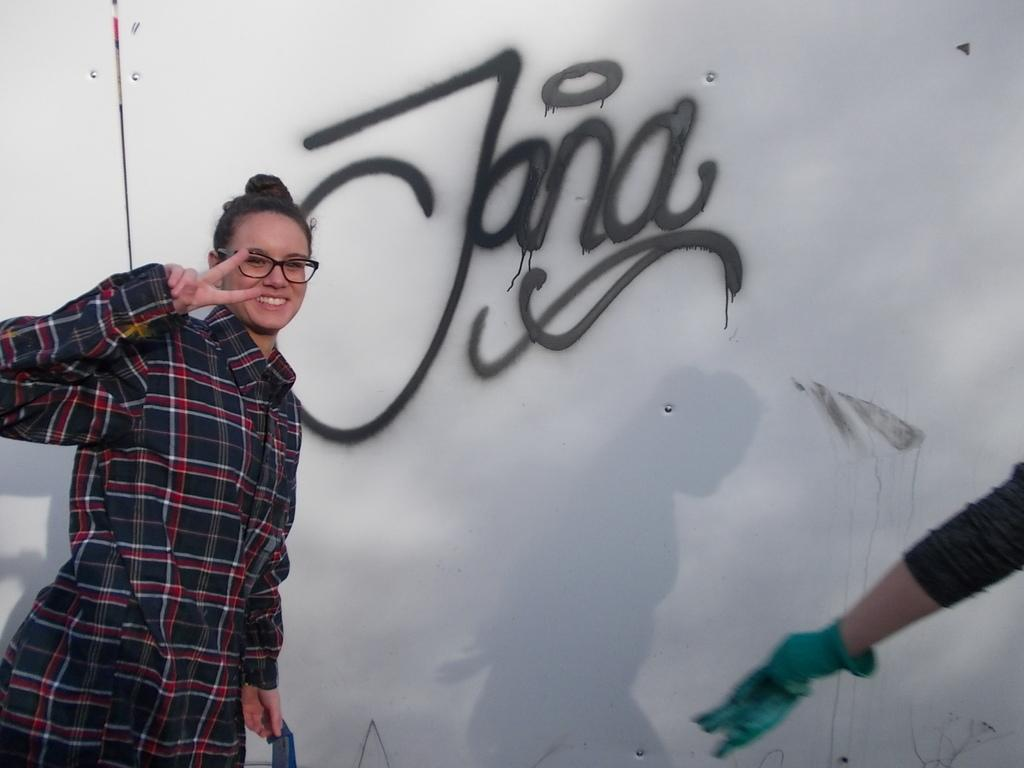Who is present in the image? There is a woman in the image. What can be seen in the background of the image? There is a painted wall visible in the background of the image. How many spiders are crawling on the woman in the image? There are no spiders visible in the image; it only features a woman and a painted wall in the background. What act is the woman performing in the image? The image does not depict the woman performing any specific act; she is simply standing or posing. 